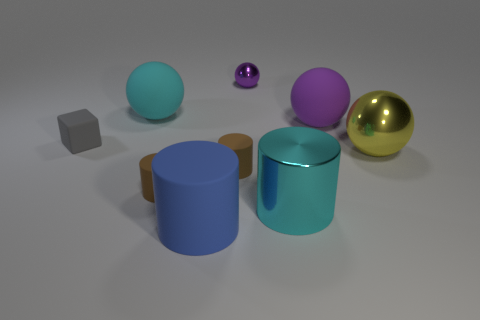Subtract all purple cylinders. How many purple spheres are left? 2 Subtract all cyan balls. How many balls are left? 3 Add 1 large blue rubber cylinders. How many objects exist? 10 Subtract 2 spheres. How many spheres are left? 2 Subtract all cyan balls. How many balls are left? 3 Subtract 0 purple cylinders. How many objects are left? 9 Subtract all balls. How many objects are left? 5 Subtract all red spheres. Subtract all blue blocks. How many spheres are left? 4 Subtract all cyan metallic objects. Subtract all tiny cubes. How many objects are left? 7 Add 6 brown rubber cylinders. How many brown rubber cylinders are left? 8 